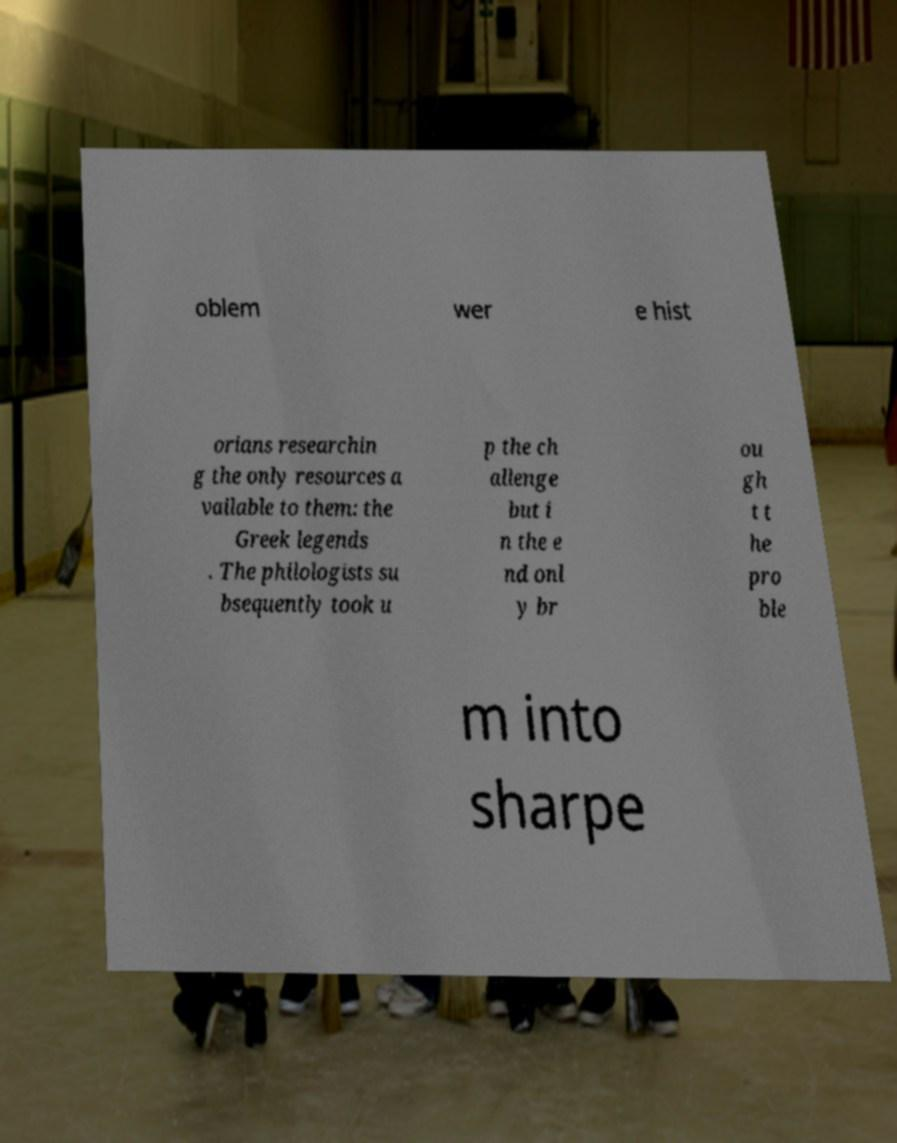Please identify and transcribe the text found in this image. oblem wer e hist orians researchin g the only resources a vailable to them: the Greek legends . The philologists su bsequently took u p the ch allenge but i n the e nd onl y br ou gh t t he pro ble m into sharpe 